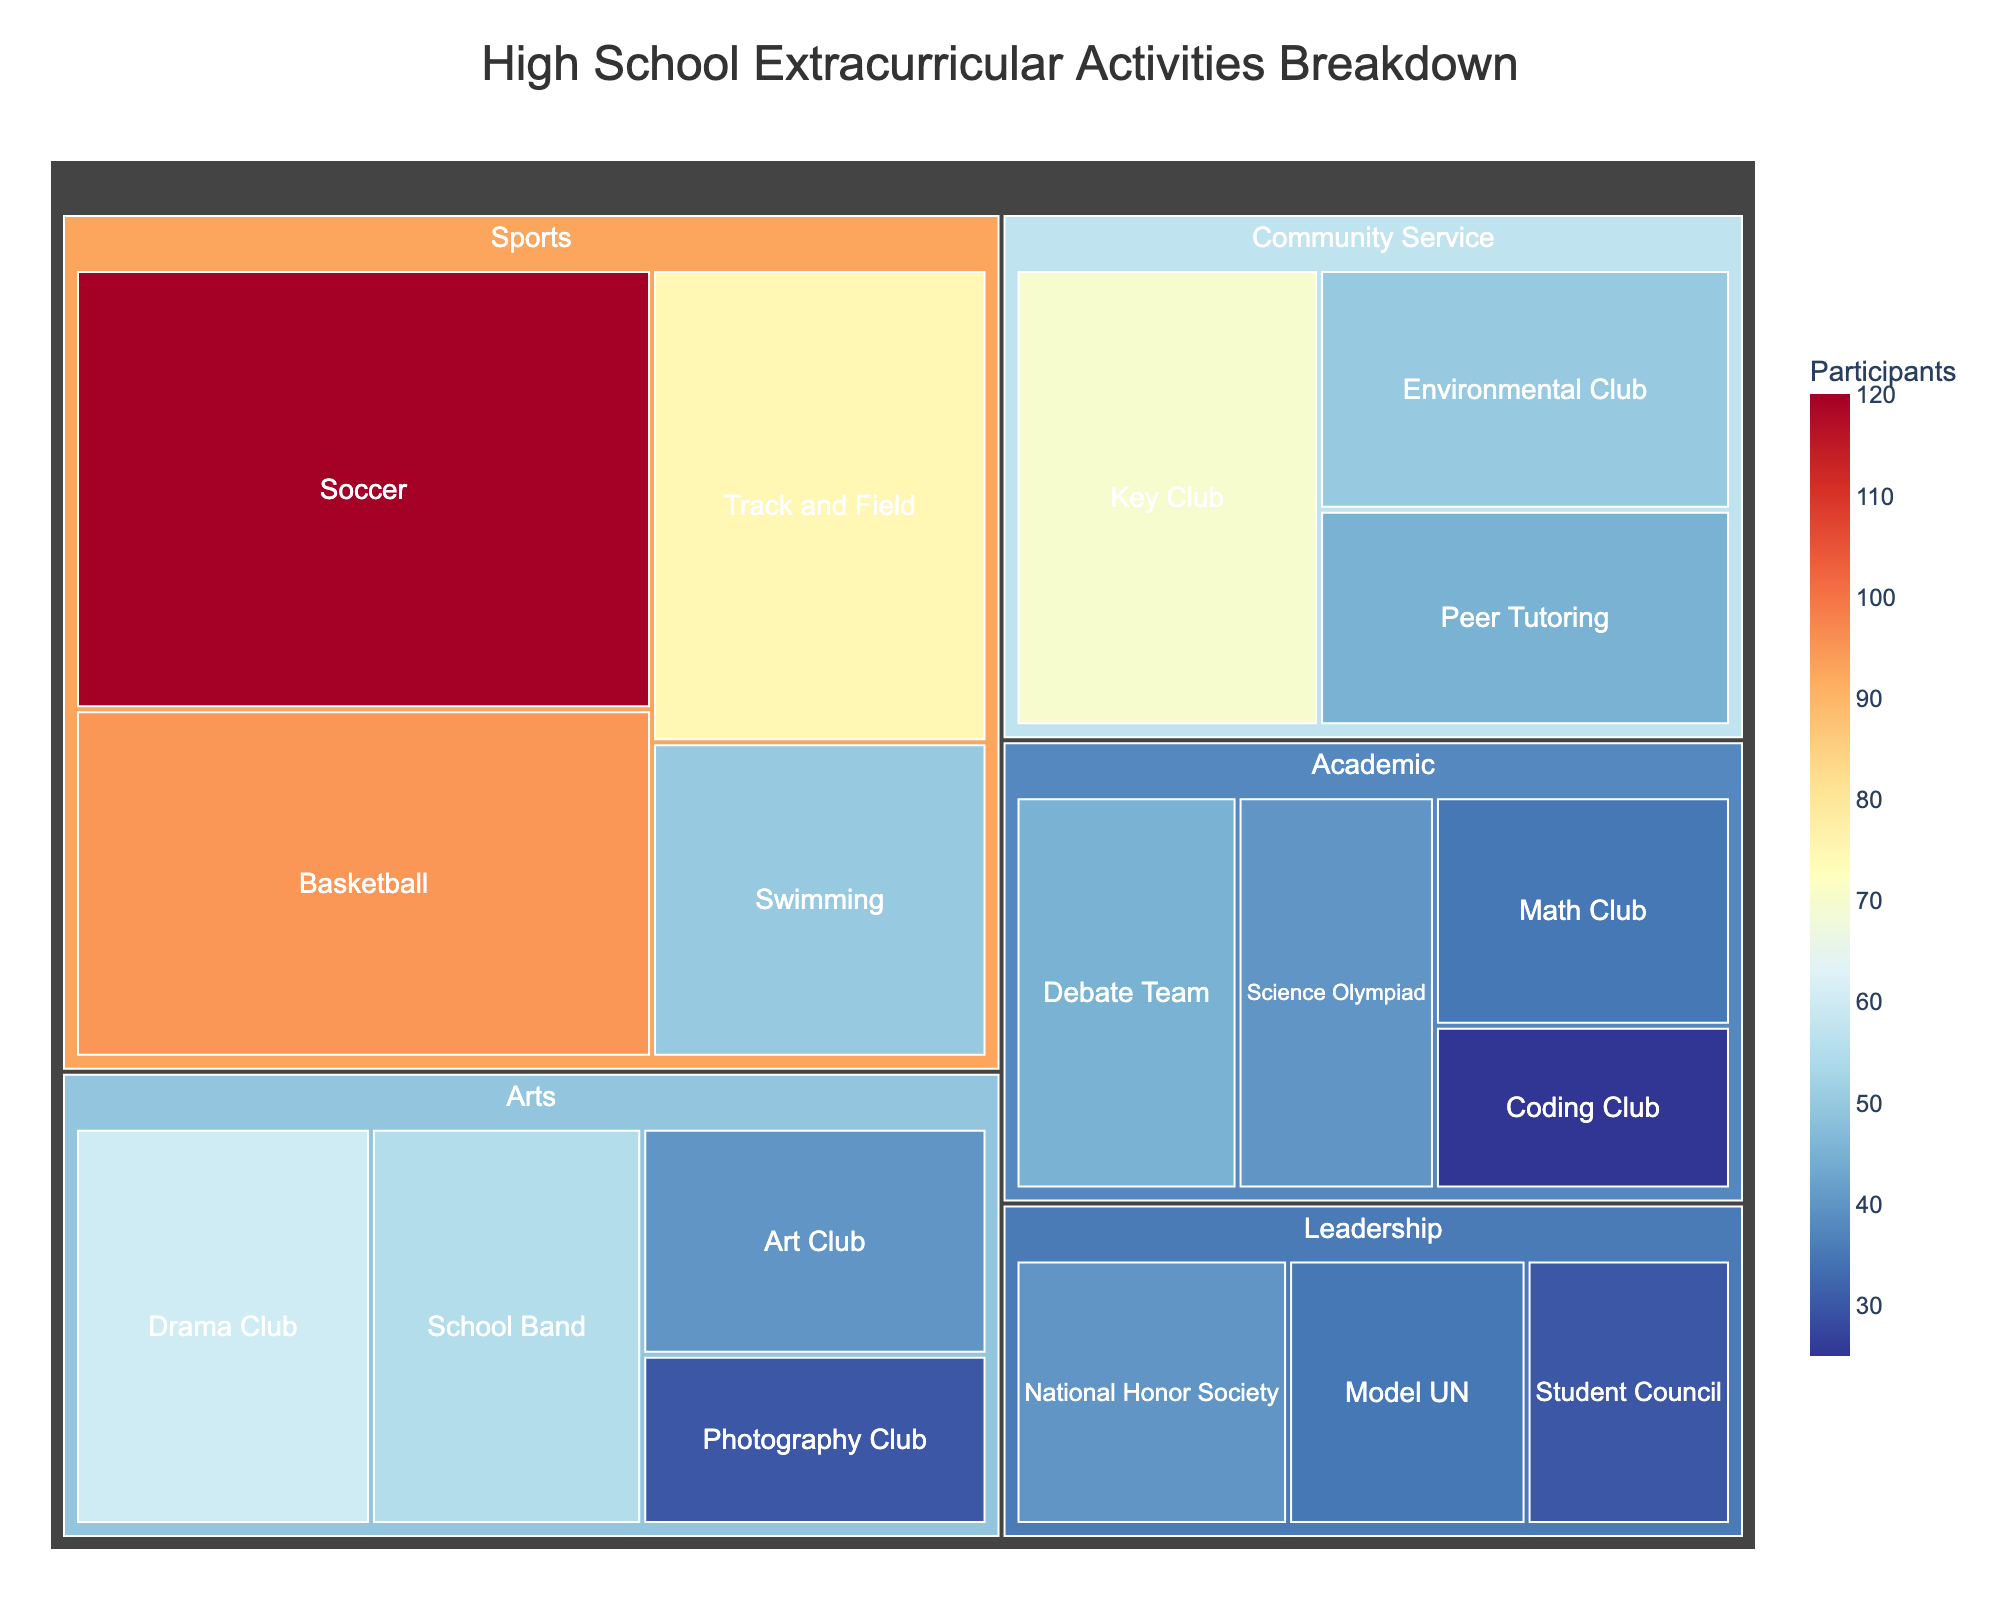What is the title of the treemap? The title of the treemap is displayed prominently at the top of the figure, indicating the main subject of the visualization. This title helps viewers understand what the visualization is about.
Answer: High School Extracurricular Activities Breakdown Which activity has the highest number of participants? To determine which activity has the highest number of participants, look for the largest rectangle or the one with the label showing the highest number in the treemap.
Answer: Soccer How many participants are there in all sports-related activities combined? Sum the number of participants in all activities under the "Sports" category. Namely, Soccer (120), Basketball (95), Track and Field (75), and Swimming (50).
Answer: 340 Which category has the least represented activity, and what is it? Identify the smallest rectangle within the entire treemap and find its parent category. The smallest rectangle will represent the activity with the fewest participants.
Answer: Leadership, Student Council Compare the number of participants in Drama Club and School Band. Which one has more, and by how many participants? Compare the number values of Drama Club and School Band. Drama Club has 60 participants, while School Band has 55 participants. Subtract the smaller from the larger number.
Answer: Drama Club by 5 participants Which category encompasses the widest variety of activities? Count the number of activities listed under each category. The category with the highest count is the answer.
Answer: Arts Is the Math Club's popularity more, less, or equal compared to the Coding Club? Compare the number of participants in Math Club (35) with those in the Coding Club (25). Determine whether one is greater, less, or if they are equal.
Answer: More How many total participants are there in all "Community Service" activities? Sum the number of participants in all activities under the "Community Service" category. Namely, Key Club (70), Environmental Club (50), and Peer Tutoring (45).
Answer: 165 What is the difference in participation between the category "Leadership" and "Academic"? Calculate the sum of participants in Leadership (Student Council: 30, National Honor Society: 40, Model UN: 35) and Academic (Debate Team: 45, Math Club: 35, Science Olympiad: 40, Coding Club: 25), then find the difference between the two sums.
Answer: 55 Which categories have activities with over 50 participants? Identify categories that have at least one activity with more than 50 participants. Look for rectangles with participant numbers above 50.
Answer: Sports, Arts, Community Service 